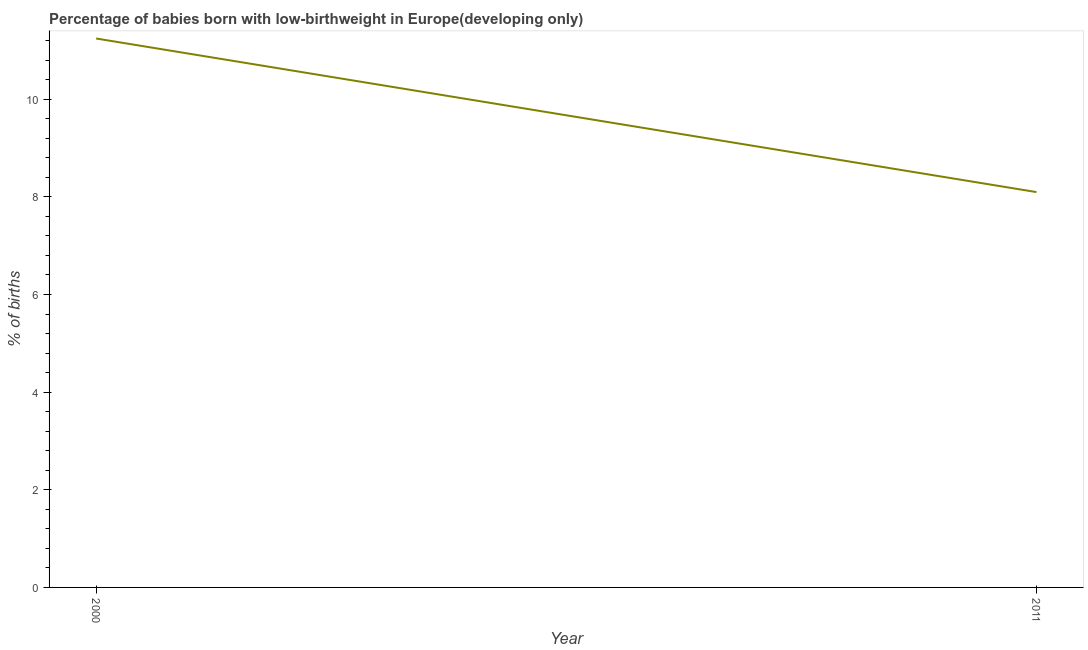What is the percentage of babies who were born with low-birthweight in 2011?
Your answer should be compact. 8.1. Across all years, what is the maximum percentage of babies who were born with low-birthweight?
Provide a short and direct response. 11.24. Across all years, what is the minimum percentage of babies who were born with low-birthweight?
Your answer should be compact. 8.1. In which year was the percentage of babies who were born with low-birthweight maximum?
Ensure brevity in your answer.  2000. In which year was the percentage of babies who were born with low-birthweight minimum?
Offer a terse response. 2011. What is the sum of the percentage of babies who were born with low-birthweight?
Your answer should be very brief. 19.34. What is the difference between the percentage of babies who were born with low-birthweight in 2000 and 2011?
Your response must be concise. 3.15. What is the average percentage of babies who were born with low-birthweight per year?
Provide a short and direct response. 9.67. What is the median percentage of babies who were born with low-birthweight?
Make the answer very short. 9.67. Do a majority of the years between 2011 and 2000 (inclusive) have percentage of babies who were born with low-birthweight greater than 4.8 %?
Offer a very short reply. No. What is the ratio of the percentage of babies who were born with low-birthweight in 2000 to that in 2011?
Ensure brevity in your answer.  1.39. Is the percentage of babies who were born with low-birthweight in 2000 less than that in 2011?
Keep it short and to the point. No. In how many years, is the percentage of babies who were born with low-birthweight greater than the average percentage of babies who were born with low-birthweight taken over all years?
Ensure brevity in your answer.  1. Does the percentage of babies who were born with low-birthweight monotonically increase over the years?
Provide a short and direct response. No. How many lines are there?
Give a very brief answer. 1. How many years are there in the graph?
Make the answer very short. 2. Does the graph contain grids?
Give a very brief answer. No. What is the title of the graph?
Offer a very short reply. Percentage of babies born with low-birthweight in Europe(developing only). What is the label or title of the X-axis?
Offer a very short reply. Year. What is the label or title of the Y-axis?
Ensure brevity in your answer.  % of births. What is the % of births of 2000?
Make the answer very short. 11.24. What is the % of births in 2011?
Make the answer very short. 8.1. What is the difference between the % of births in 2000 and 2011?
Provide a short and direct response. 3.15. What is the ratio of the % of births in 2000 to that in 2011?
Keep it short and to the point. 1.39. 